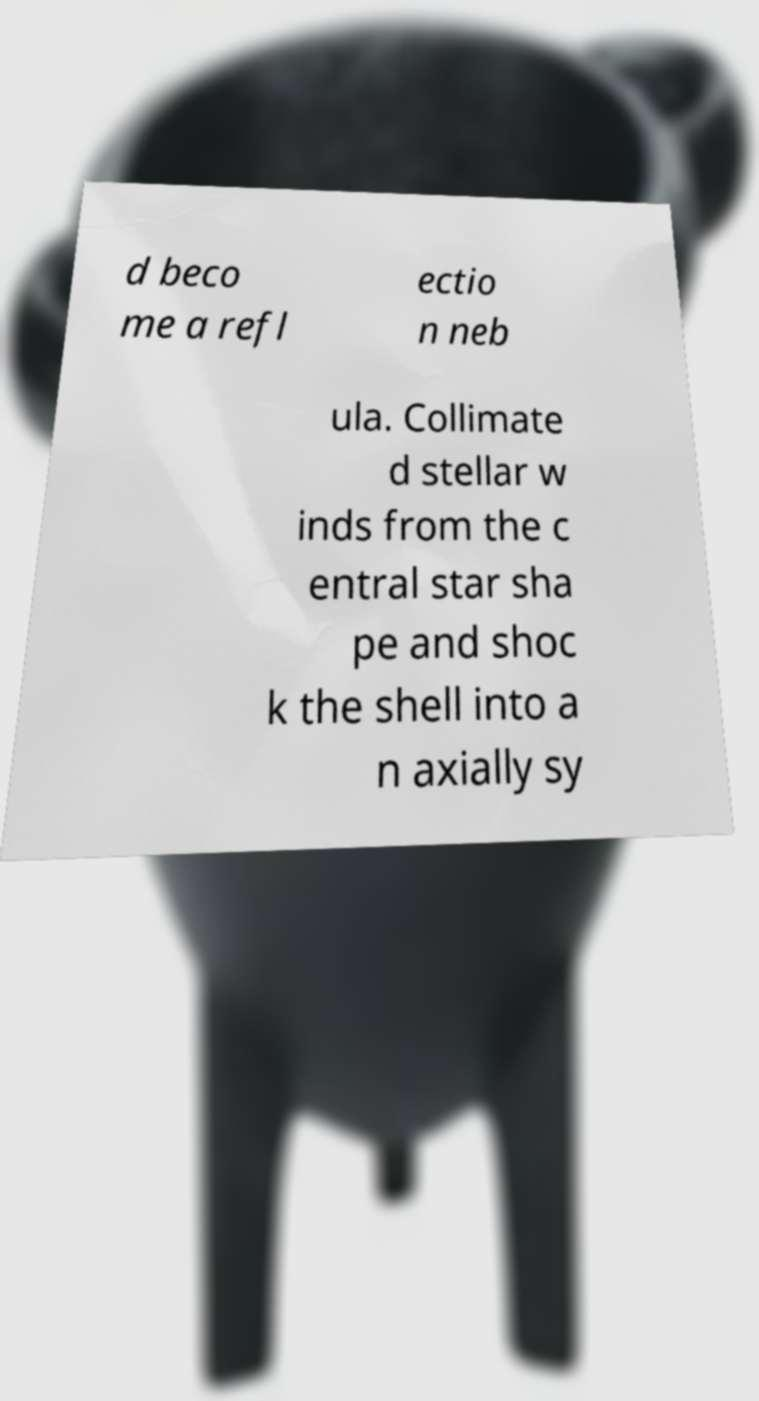Please read and relay the text visible in this image. What does it say? d beco me a refl ectio n neb ula. Collimate d stellar w inds from the c entral star sha pe and shoc k the shell into a n axially sy 